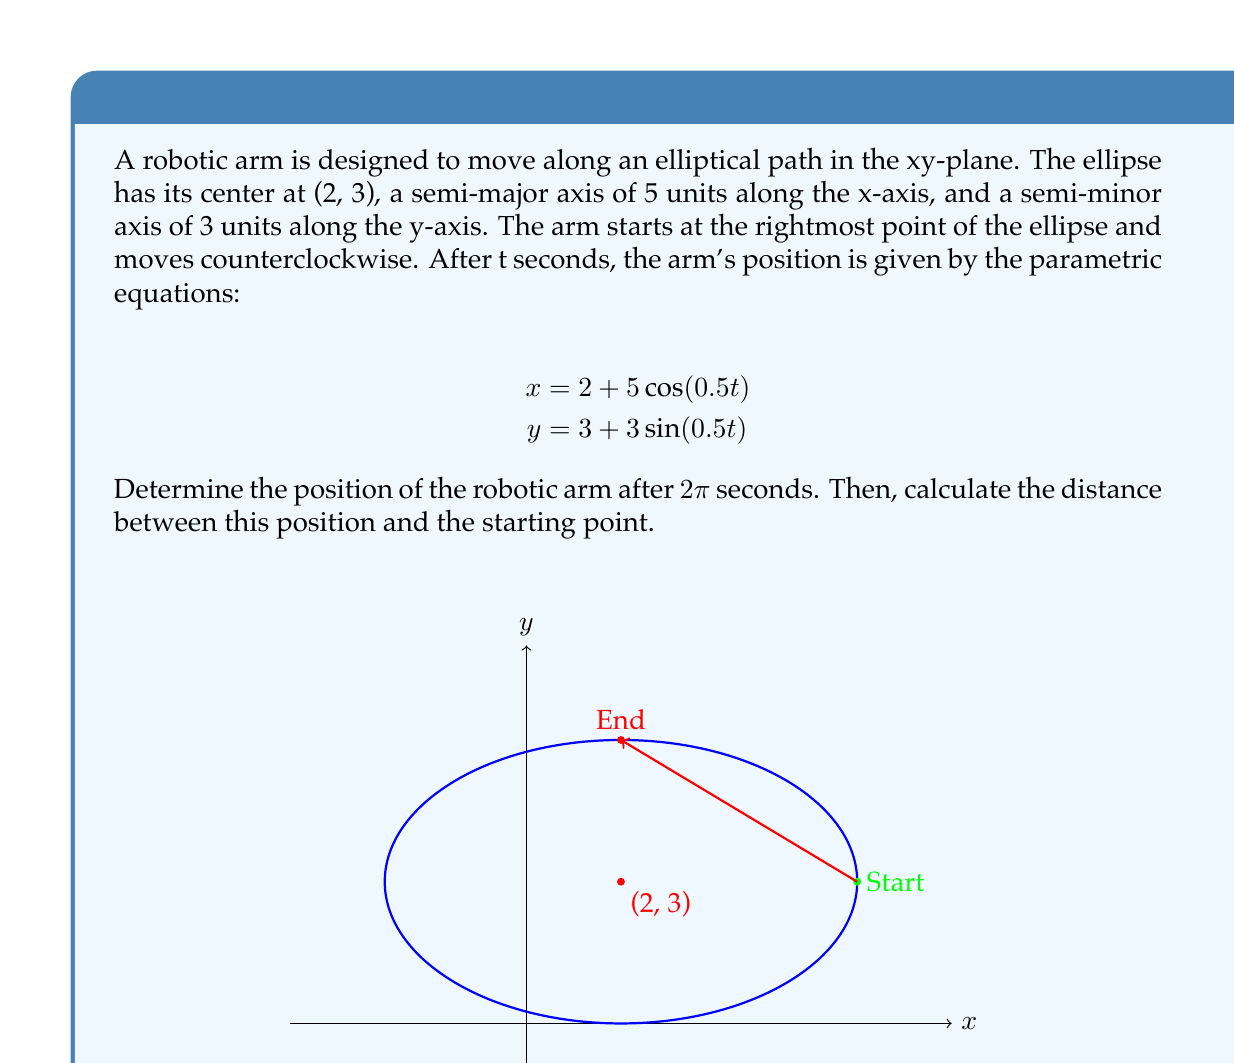Could you help me with this problem? Let's approach this step-by-step:

1) First, we need to find the position after 2π seconds. We can do this by substituting t = 2π into the parametric equations:

   $$x = 2 + 5\cos(0.5(2\pi)) = 2 + 5\cos(\pi) = 2 - 5 = -3$$
   $$y = 3 + 3\sin(0.5(2\pi)) = 3 + 3\sin(\pi) = 3 + 0 = 3$$

   So, after 2π seconds, the arm is at position (-3, 3).

2) Now, we need to find the distance between this point and the starting point.
   The starting point is at t = 0, which gives us:
   
   $$x = 2 + 5\cos(0) = 2 + 5 = 7$$
   $$y = 3 + 3\sin(0) = 3 + 0 = 3$$

   So, the starting point is (7, 3).

3) To find the distance between (-3, 3) and (7, 3), we can use the distance formula:

   $$d = \sqrt{(x_2-x_1)^2 + (y_2-y_1)^2}$$

   Where (x₁, y₁) = (-3, 3) and (x₂, y₂) = (7, 3)

4) Plugging in these values:

   $$d = \sqrt{(7-(-3))^2 + (3-3)^2} = \sqrt{10^2 + 0^2} = \sqrt{100} = 10$$

Therefore, the distance between the arm's position after 2π seconds and its starting point is 10 units.
Answer: (-3, 3); 10 units 